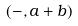Convert formula to latex. <formula><loc_0><loc_0><loc_500><loc_500>( - , a + b )</formula> 